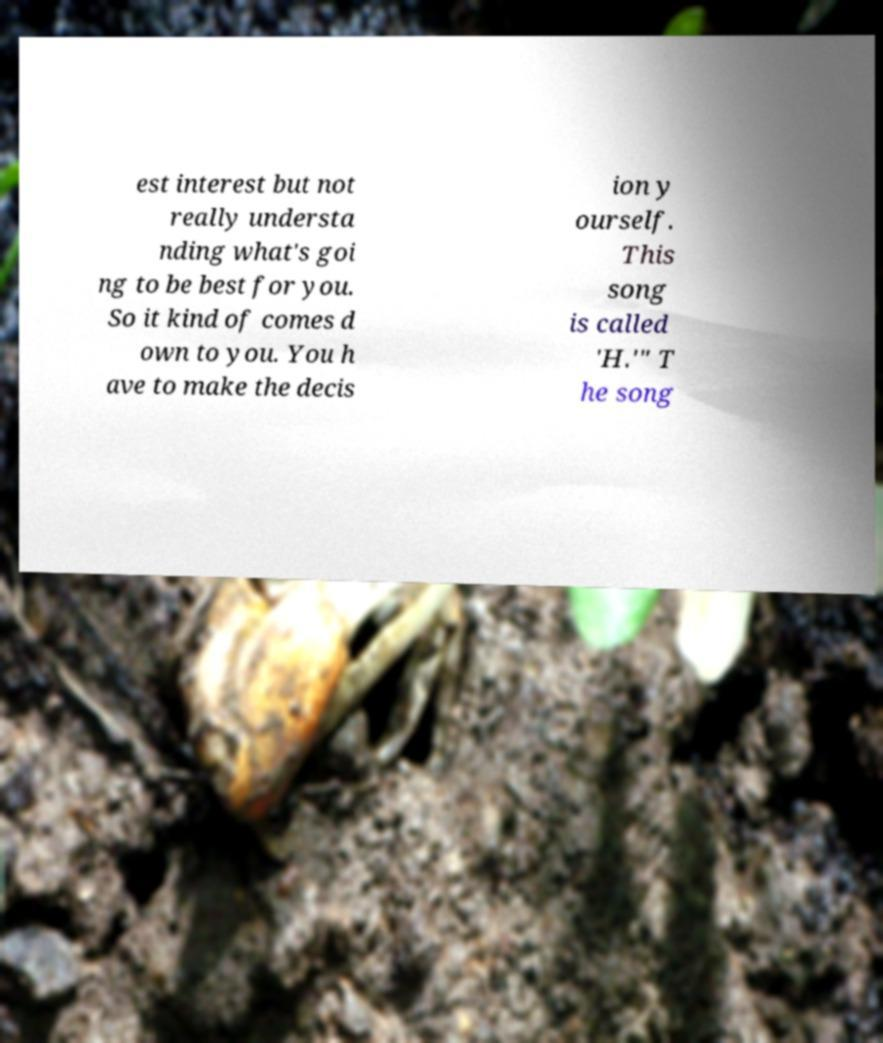Can you read and provide the text displayed in the image?This photo seems to have some interesting text. Can you extract and type it out for me? est interest but not really understa nding what's goi ng to be best for you. So it kind of comes d own to you. You h ave to make the decis ion y ourself. This song is called 'H.'" T he song 